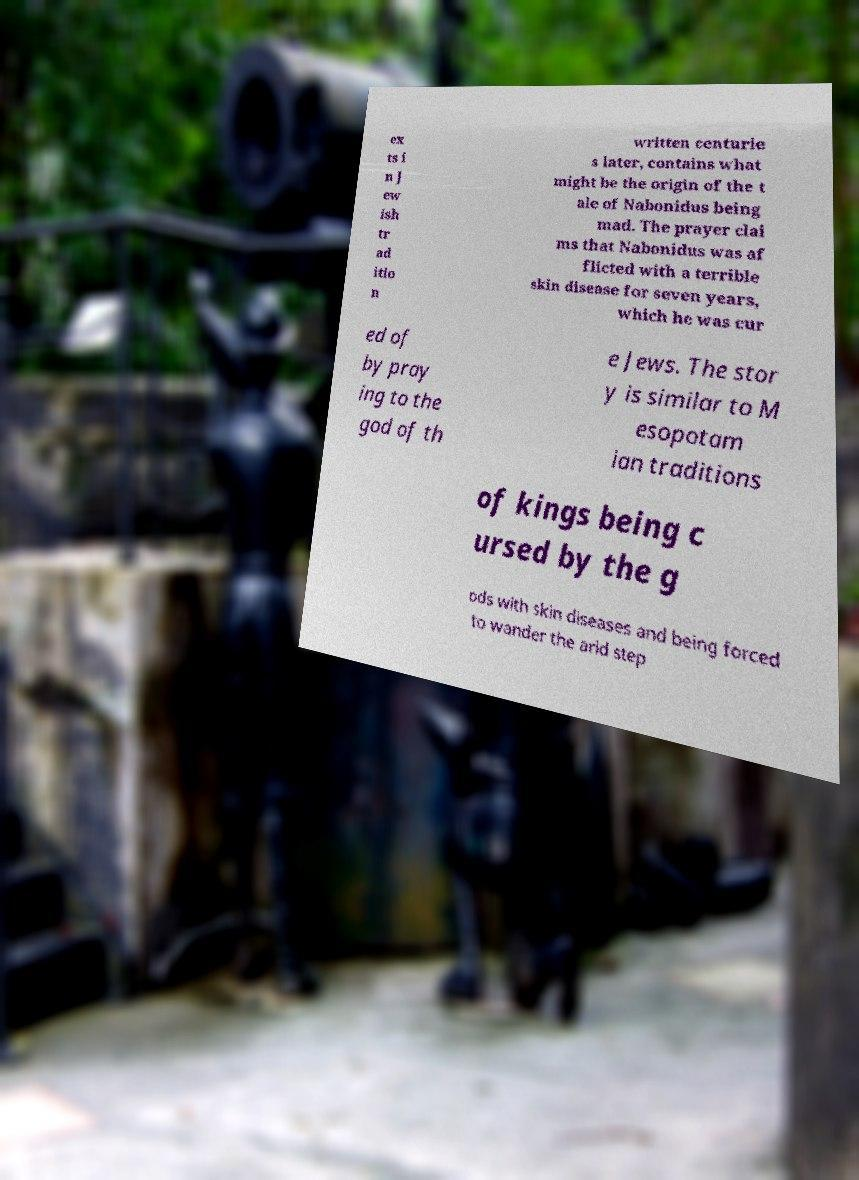There's text embedded in this image that I need extracted. Can you transcribe it verbatim? ex ts i n J ew ish tr ad itio n written centurie s later, contains what might be the origin of the t ale of Nabonidus being mad. The prayer clai ms that Nabonidus was af flicted with a terrible skin disease for seven years, which he was cur ed of by pray ing to the god of th e Jews. The stor y is similar to M esopotam ian traditions of kings being c ursed by the g ods with skin diseases and being forced to wander the arid step 